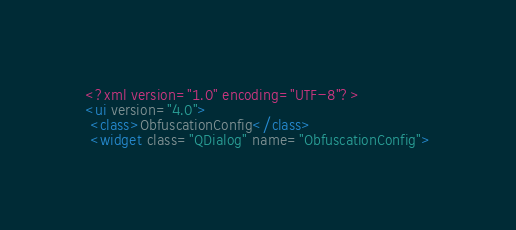<code> <loc_0><loc_0><loc_500><loc_500><_XML_><?xml version="1.0" encoding="UTF-8"?>
<ui version="4.0">
 <class>ObfuscationConfig</class>
 <widget class="QDialog" name="ObfuscationConfig"></code> 